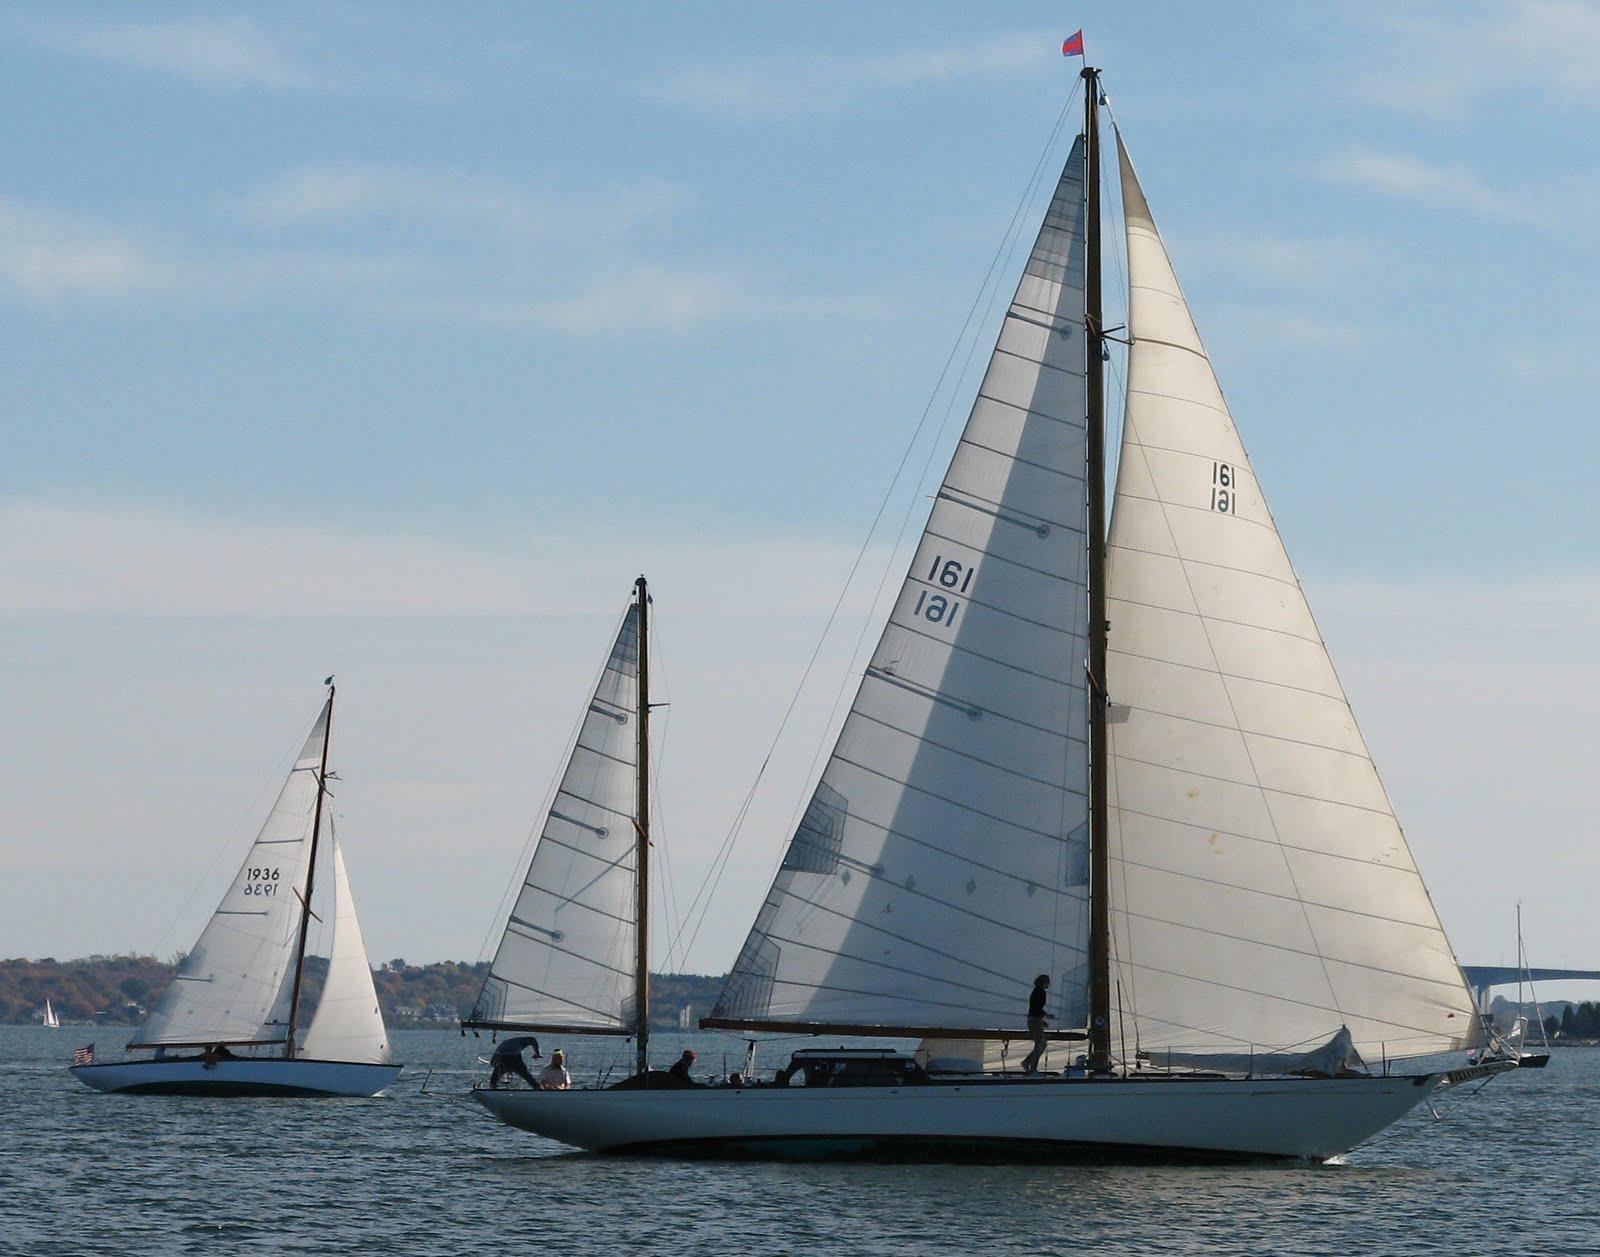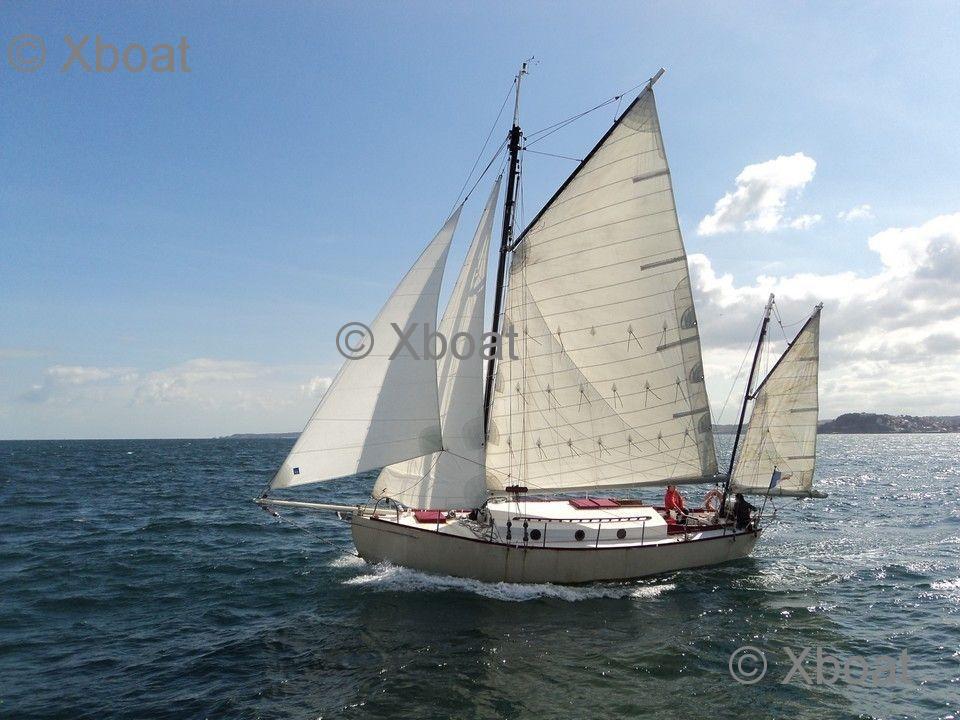The first image is the image on the left, the second image is the image on the right. Analyze the images presented: Is the assertion "There are exactly two sailboats on the water." valid? Answer yes or no. No. The first image is the image on the left, the second image is the image on the right. Analyze the images presented: Is the assertion "There are at least three sailboats on the water." valid? Answer yes or no. Yes. 